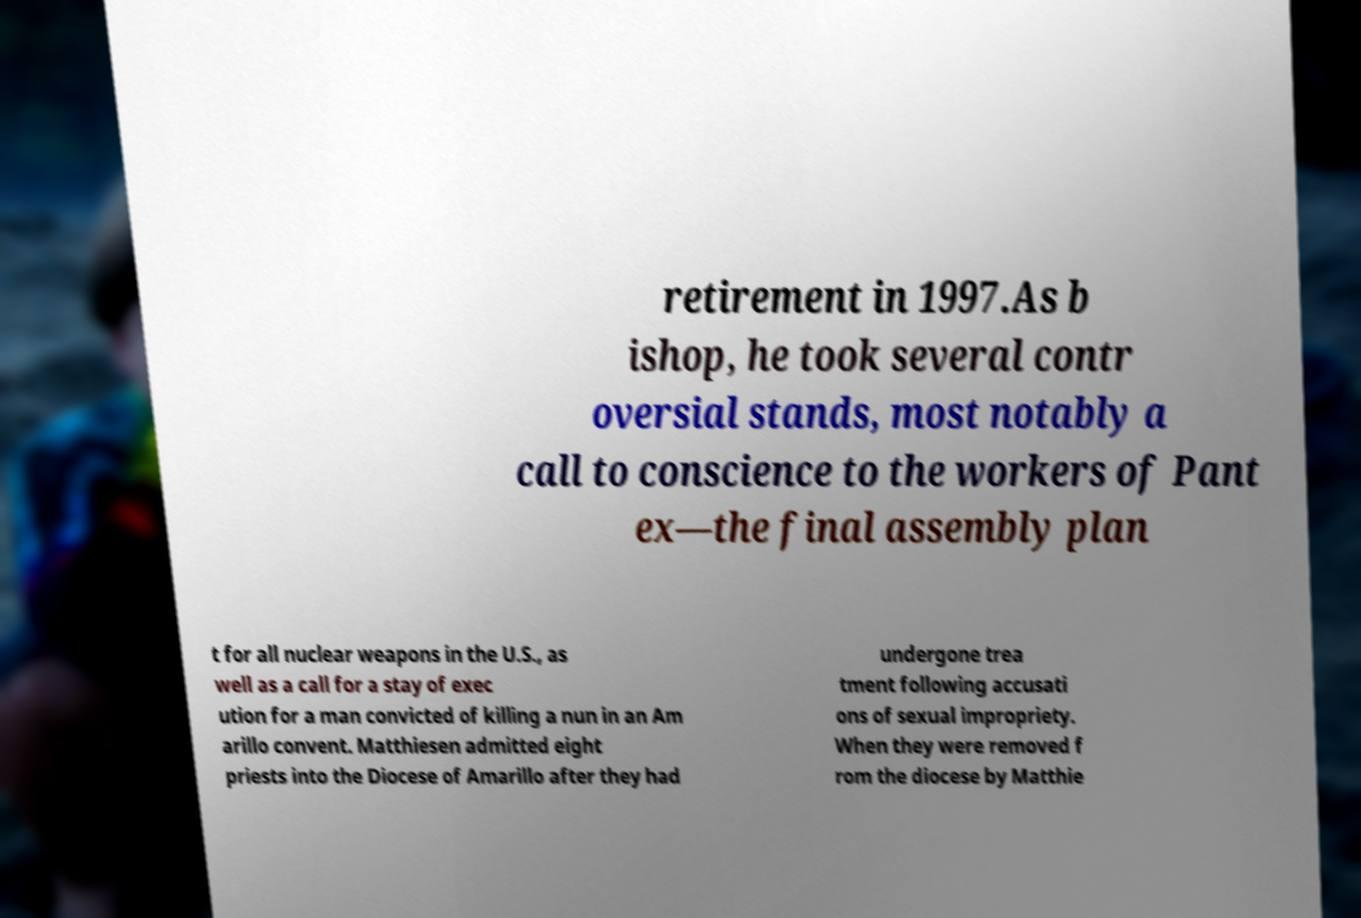I need the written content from this picture converted into text. Can you do that? retirement in 1997.As b ishop, he took several contr oversial stands, most notably a call to conscience to the workers of Pant ex—the final assembly plan t for all nuclear weapons in the U.S., as well as a call for a stay of exec ution for a man convicted of killing a nun in an Am arillo convent. Matthiesen admitted eight priests into the Diocese of Amarillo after they had undergone trea tment following accusati ons of sexual impropriety. When they were removed f rom the diocese by Matthie 